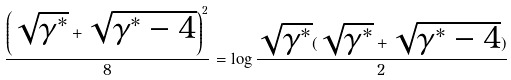<formula> <loc_0><loc_0><loc_500><loc_500>\frac { { \left ( { { \sqrt { \gamma ^ { * } } + \sqrt { \gamma ^ { * } - 4 } } } \right ) } ^ { 2 } } { 8 } = \log \frac { \sqrt { \gamma ^ { * } } ( \sqrt { \gamma ^ { * } } + \sqrt { \gamma ^ { * } - 4 } ) } { 2 }</formula> 